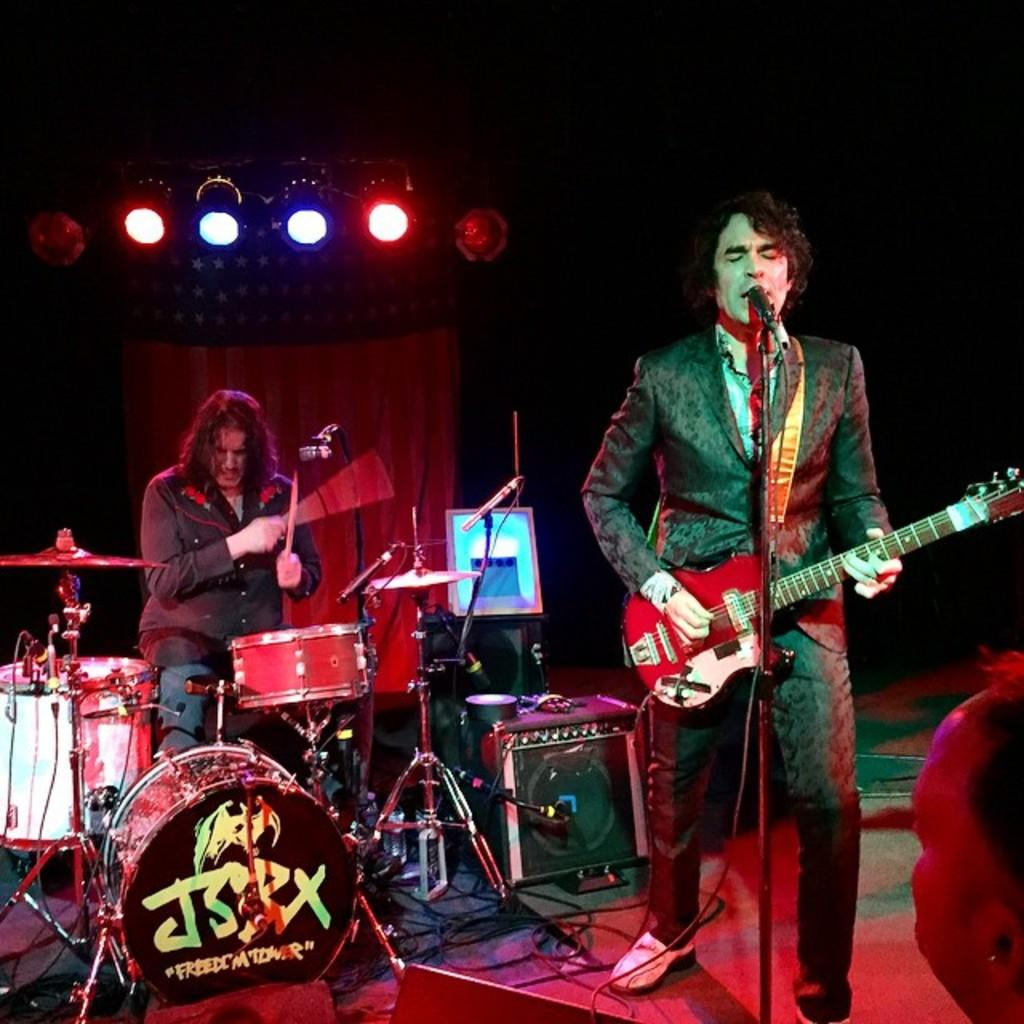What is the man in the image holding? The man is holding a guitar in the image. What is the man doing with the guitar? The man is playing the guitar. What is in front of the man playing the guitar? There is a microphone in front of the man playing the guitar. What is the second man in the image doing? The second man is playing the drums. What can be seen in the image that might be used for illumination? There are lights visible in the image. What type of yam is being used as a drumstick by the second man in the image? There is no yam present in the image, and the second man is using drumsticks, not yams, to play the drums. Who is the partner of the man playing the guitar in the image? The provided facts do not mention any partners or relationships between the individuals in the image. 